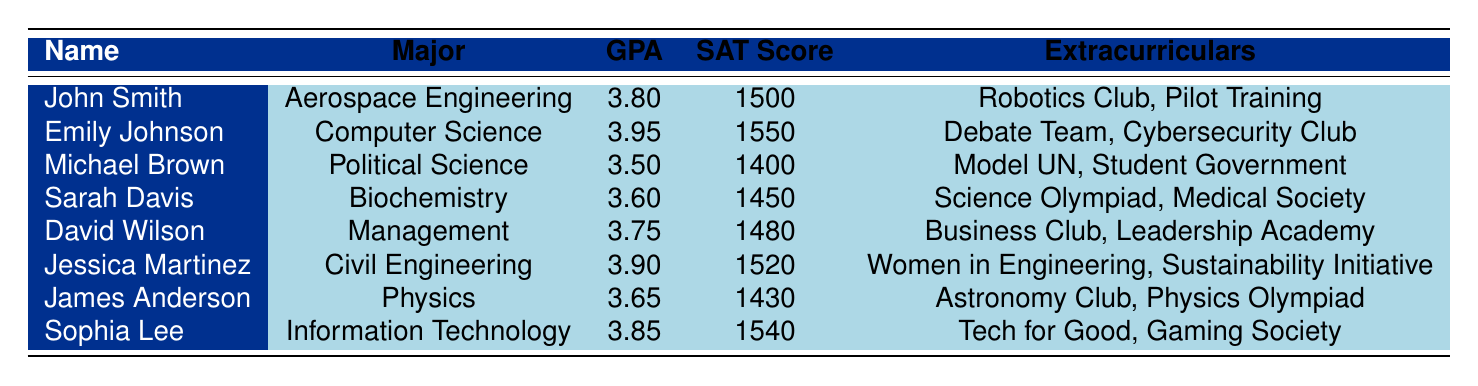What is the GPA of Emily Johnson? Emily Johnson's GPA is listed directly in the table. Under her row, the GPA is shown as 3.95.
Answer: 3.95 Which major has the lowest SAT score? By comparing the SAT scores listed for each major in the table, Michael Brown with a major in Political Science has the lowest SAT score at 1400.
Answer: Political Science What is the average GPA of the students listed? To find the average GPA, sum all the GPAs: 3.80 + 3.95 + 3.50 + 3.60 + 3.75 + 3.90 + 3.65 + 3.85 = 30.10. There are 8 students, so the average GPA is 30.10 / 8 = 3.76.
Answer: 3.76 Does any student have a higher GPA than their SAT score divided by 400? Divide the SAT scores by 400 to check: for example, Emily Johnson has a SAT score of 1550, which is 1550 / 400 = 3.875, and her GPA is 3.95, which is higher. Checking all students shows that 5 out of the 8 students have GPAs higher than SAT/400.
Answer: Yes Which student is involved in the most extracurricular activities according to the table? The extracurricular activities are counted from each student's listing. John Smith, Michael Brown, and Sarah Davis are involved in 2 activities each; however, there’s no one listed with more than 2. Each listed student has 2 extracurricular activities.
Answer: No single student has more Consider the total number of students with a GPA above 3.80. How many are there? The students with a GPA above 3.80 are: Emily Johnson (3.95), Jessica Martinez (3.90), and Sophia Lee (3.85). Counting these gives a total of 3 students.
Answer: 3 Is there any student majoring in Engineering with a SAT score greater than 1500? From the table, the engineering majors are Aerospace Engineering (John Smith) with SAT 1500 and Civil Engineering (Jessica Martinez) with SAT 1520. Jessica has a SAT score greater than 1500, confirming there is at least one such student.
Answer: Yes How many students are majoring in Management or Political Science? There is one student majoring in Management (David Wilson) and one majoring in Political Science (Michael Brown). Therefore, the total number of students in these majors is 1 + 1 = 2.
Answer: 2 